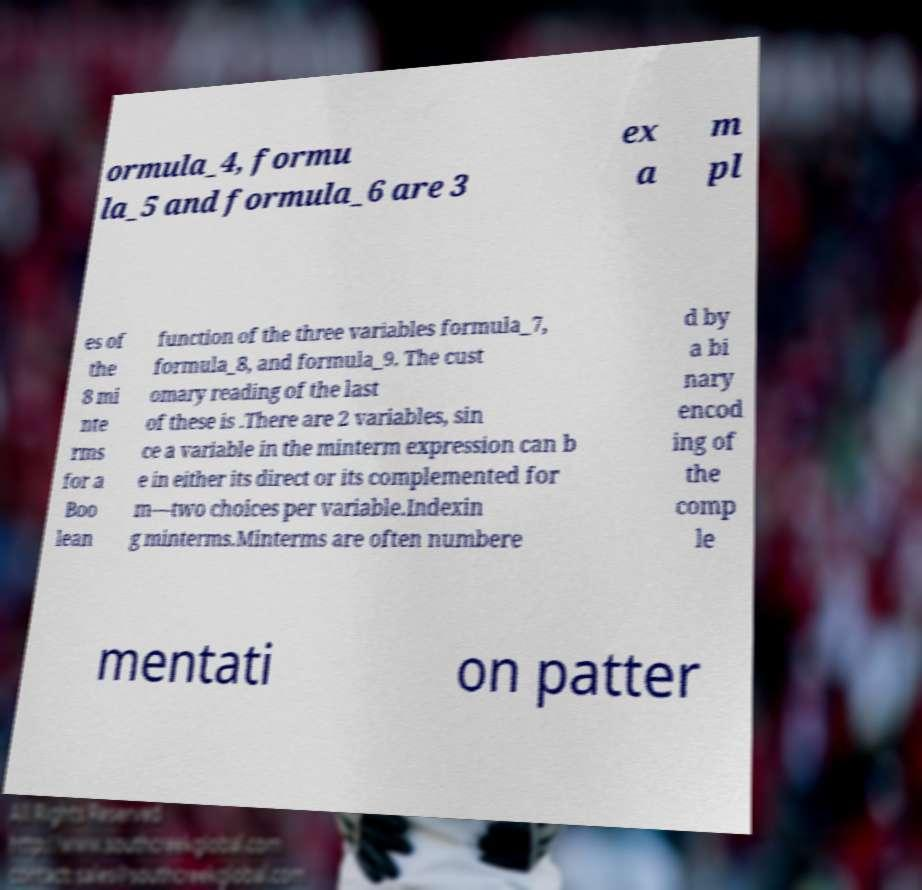I need the written content from this picture converted into text. Can you do that? ormula_4, formu la_5 and formula_6 are 3 ex a m pl es of the 8 mi nte rms for a Boo lean function of the three variables formula_7, formula_8, and formula_9. The cust omary reading of the last of these is .There are 2 variables, sin ce a variable in the minterm expression can b e in either its direct or its complemented for m—two choices per variable.Indexin g minterms.Minterms are often numbere d by a bi nary encod ing of the comp le mentati on patter 